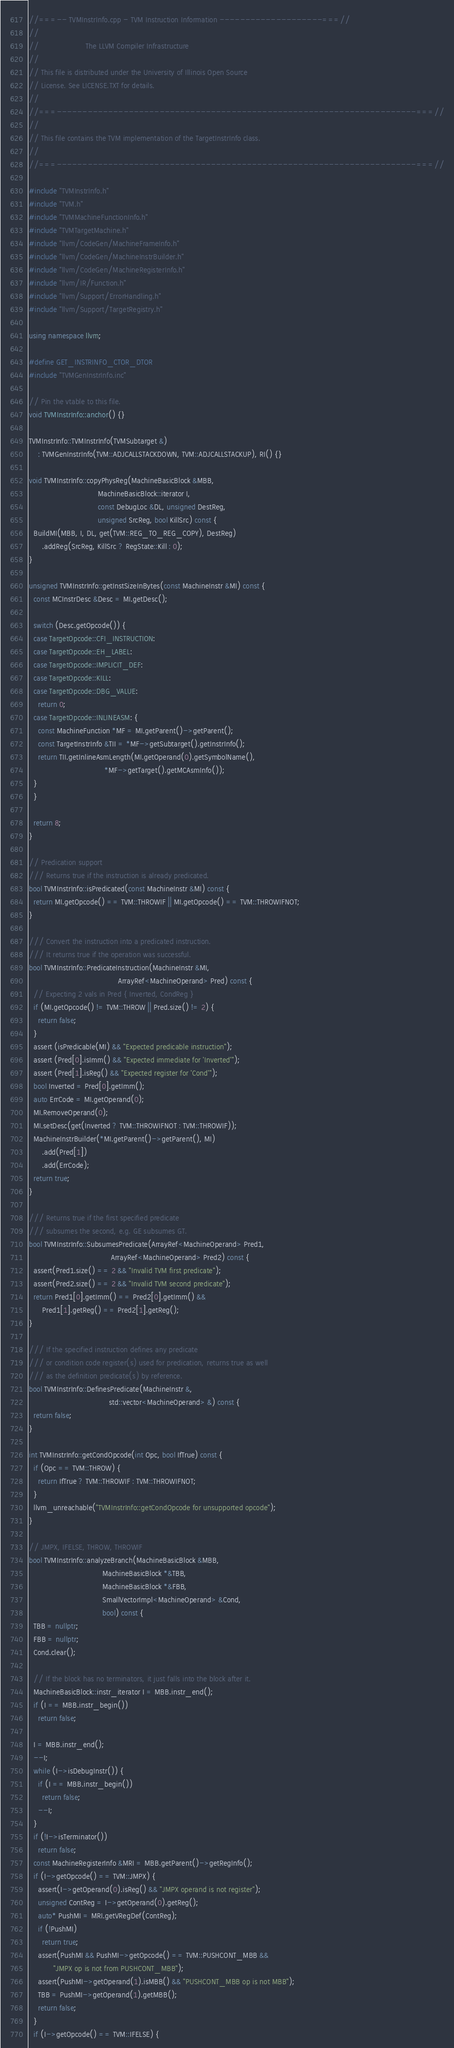Convert code to text. <code><loc_0><loc_0><loc_500><loc_500><_C++_>//===-- TVMInstrInfo.cpp - TVM Instruction Information --------------------===//
//
//                     The LLVM Compiler Infrastructure
//
// This file is distributed under the University of Illinois Open Source
// License. See LICENSE.TXT for details.
//
//===----------------------------------------------------------------------===//
//
// This file contains the TVM implementation of the TargetInstrInfo class.
//
//===----------------------------------------------------------------------===//

#include "TVMInstrInfo.h"
#include "TVM.h"
#include "TVMMachineFunctionInfo.h"
#include "TVMTargetMachine.h"
#include "llvm/CodeGen/MachineFrameInfo.h"
#include "llvm/CodeGen/MachineInstrBuilder.h"
#include "llvm/CodeGen/MachineRegisterInfo.h"
#include "llvm/IR/Function.h"
#include "llvm/Support/ErrorHandling.h"
#include "llvm/Support/TargetRegistry.h"

using namespace llvm;

#define GET_INSTRINFO_CTOR_DTOR
#include "TVMGenInstrInfo.inc"

// Pin the vtable to this file.
void TVMInstrInfo::anchor() {}

TVMInstrInfo::TVMInstrInfo(TVMSubtarget &)
    : TVMGenInstrInfo(TVM::ADJCALLSTACKDOWN, TVM::ADJCALLSTACKUP), RI() {}

void TVMInstrInfo::copyPhysReg(MachineBasicBlock &MBB,
                               MachineBasicBlock::iterator I,
                               const DebugLoc &DL, unsigned DestReg,
                               unsigned SrcReg, bool KillSrc) const {
  BuildMI(MBB, I, DL, get(TVM::REG_TO_REG_COPY), DestReg)
      .addReg(SrcReg, KillSrc ? RegState::Kill : 0);
}

unsigned TVMInstrInfo::getInstSizeInBytes(const MachineInstr &MI) const {
  const MCInstrDesc &Desc = MI.getDesc();

  switch (Desc.getOpcode()) {
  case TargetOpcode::CFI_INSTRUCTION:
  case TargetOpcode::EH_LABEL:
  case TargetOpcode::IMPLICIT_DEF:
  case TargetOpcode::KILL:
  case TargetOpcode::DBG_VALUE:
    return 0;
  case TargetOpcode::INLINEASM: {
    const MachineFunction *MF = MI.getParent()->getParent();
    const TargetInstrInfo &TII = *MF->getSubtarget().getInstrInfo();
    return TII.getInlineAsmLength(MI.getOperand(0).getSymbolName(),
                                  *MF->getTarget().getMCAsmInfo());
  }
  }

  return 8;
}

// Predication support
/// Returns true if the instruction is already predicated.
bool TVMInstrInfo::isPredicated(const MachineInstr &MI) const {
  return MI.getOpcode() == TVM::THROWIF || MI.getOpcode() == TVM::THROWIFNOT;
}

/// Convert the instruction into a predicated instruction.
/// It returns true if the operation was successful.
bool TVMInstrInfo::PredicateInstruction(MachineInstr &MI,
                                        ArrayRef<MachineOperand> Pred) const {
  // Expecting 2 vals in Pred { Inverted, CondReg }
  if (MI.getOpcode() != TVM::THROW || Pred.size() != 2) {
    return false;
  }
  assert (isPredicable(MI) && "Expected predicable instruction");
  assert (Pred[0].isImm() && "Expected immediate for 'Inverted'");
  assert (Pred[1].isReg() && "Expected register for 'Cond'");
  bool Inverted = Pred[0].getImm();
  auto ErrCode = MI.getOperand(0);
  MI.RemoveOperand(0);
  MI.setDesc(get(Inverted ? TVM::THROWIFNOT : TVM::THROWIF));
  MachineInstrBuilder(*MI.getParent()->getParent(), MI)
      .add(Pred[1])
      .add(ErrCode);
  return true;
}

/// Returns true if the first specified predicate
/// subsumes the second, e.g. GE subsumes GT.
bool TVMInstrInfo::SubsumesPredicate(ArrayRef<MachineOperand> Pred1,
                                     ArrayRef<MachineOperand> Pred2) const {
  assert(Pred1.size() == 2 && "Invalid TVM first predicate");
  assert(Pred2.size() == 2 && "Invalid TVM second predicate");
  return Pred1[0].getImm() == Pred2[0].getImm() &&
      Pred1[1].getReg() == Pred2[1].getReg();
}

/// If the specified instruction defines any predicate
/// or condition code register(s) used for predication, returns true as well
/// as the definition predicate(s) by reference.
bool TVMInstrInfo::DefinesPredicate(MachineInstr &,
                                    std::vector<MachineOperand> &) const {
  return false;
}

int TVMInstrInfo::getCondOpcode(int Opc, bool IfTrue) const {
  if (Opc == TVM::THROW) {
    return IfTrue ? TVM::THROWIF : TVM::THROWIFNOT;
  }
  llvm_unreachable("TVMInstrInfo::getCondOpcode for unsupported opcode");
}

// JMPX, IFELSE, THROW, THROWIF
bool TVMInstrInfo::analyzeBranch(MachineBasicBlock &MBB,
                                 MachineBasicBlock *&TBB,
                                 MachineBasicBlock *&FBB,
                                 SmallVectorImpl<MachineOperand> &Cond,
                                 bool) const {
  TBB = nullptr;
  FBB = nullptr;
  Cond.clear();

  // If the block has no terminators, it just falls into the block after it.
  MachineBasicBlock::instr_iterator I = MBB.instr_end();
  if (I == MBB.instr_begin())
    return false;

  I = MBB.instr_end();
  --I;
  while (I->isDebugInstr()) {
    if (I == MBB.instr_begin())
      return false;
    --I;
  }
  if (!I->isTerminator())
    return false;
  const MachineRegisterInfo &MRI = MBB.getParent()->getRegInfo();
  if (I->getOpcode() == TVM::JMPX) {
    assert(I->getOperand(0).isReg() && "JMPX operand is not register");
    unsigned ContReg = I->getOperand(0).getReg();
    auto* PushMI = MRI.getVRegDef(ContReg);
    if (!PushMI)
      return true;
    assert(PushMI && PushMI->getOpcode() == TVM::PUSHCONT_MBB &&
           "JMPX op is not from PUSHCONT_MBB");
    assert(PushMI->getOperand(1).isMBB() && "PUSHCONT_MBB op is not MBB");
    TBB = PushMI->getOperand(1).getMBB();
    return false;
  }
  if (I->getOpcode() == TVM::IFELSE) {</code> 